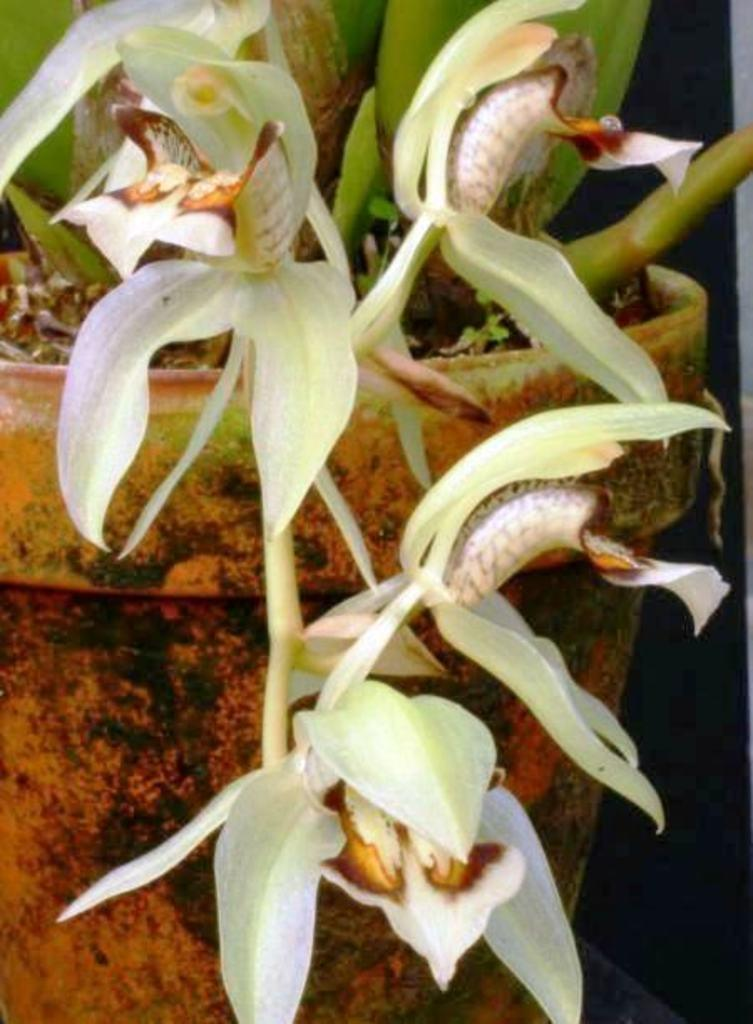What type of living organism is present in the image? There is a plant in the image. How is the plant contained or displayed in the image? The plant is placed in a flower pot. What additional features can be seen in the image? There are flowers in the image. How many cannons are present in the image? There are no cannons present in the image. What type of lizards can be seen in the image? There are no lizards present in the image. 